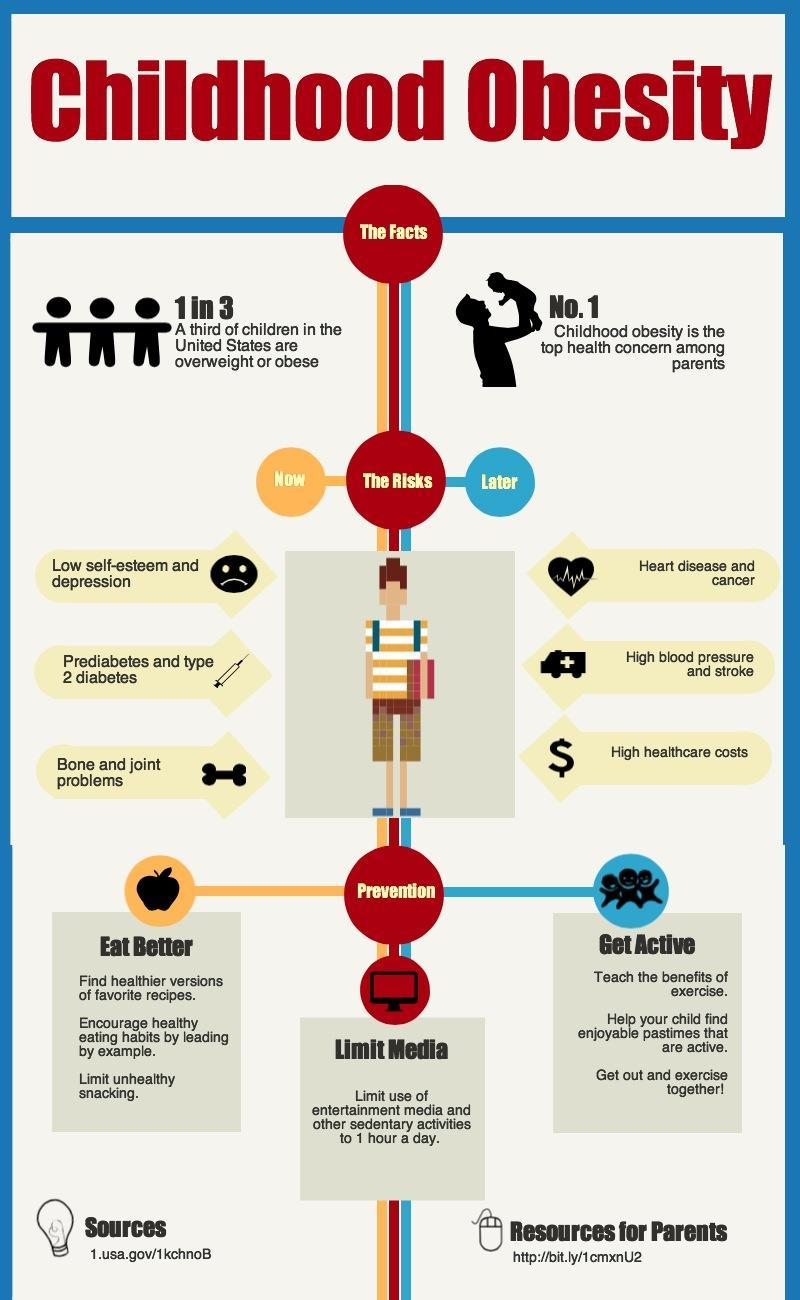What are the three ways to prevent childhood obesity?
Answer the question with a short phrase. Eat Better, Limit Media, Get Active 